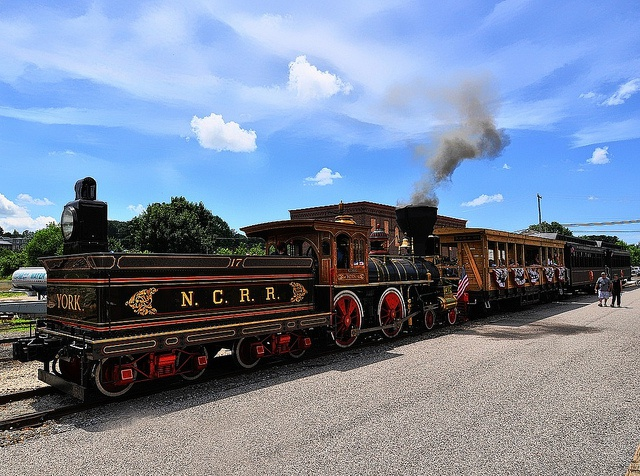Describe the objects in this image and their specific colors. I can see train in lightblue, black, maroon, and gray tones, people in lightblue, black, gray, darkgray, and maroon tones, people in lightblue, black, gray, maroon, and darkgray tones, people in lightblue, black, maroon, and brown tones, and people in lightblue, black, and gray tones in this image. 